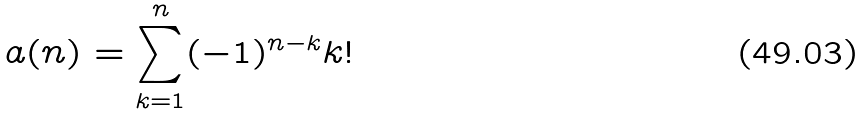Convert formula to latex. <formula><loc_0><loc_0><loc_500><loc_500>a ( n ) = \sum _ { k = 1 } ^ { n } ( - 1 ) ^ { n - k } k !</formula> 